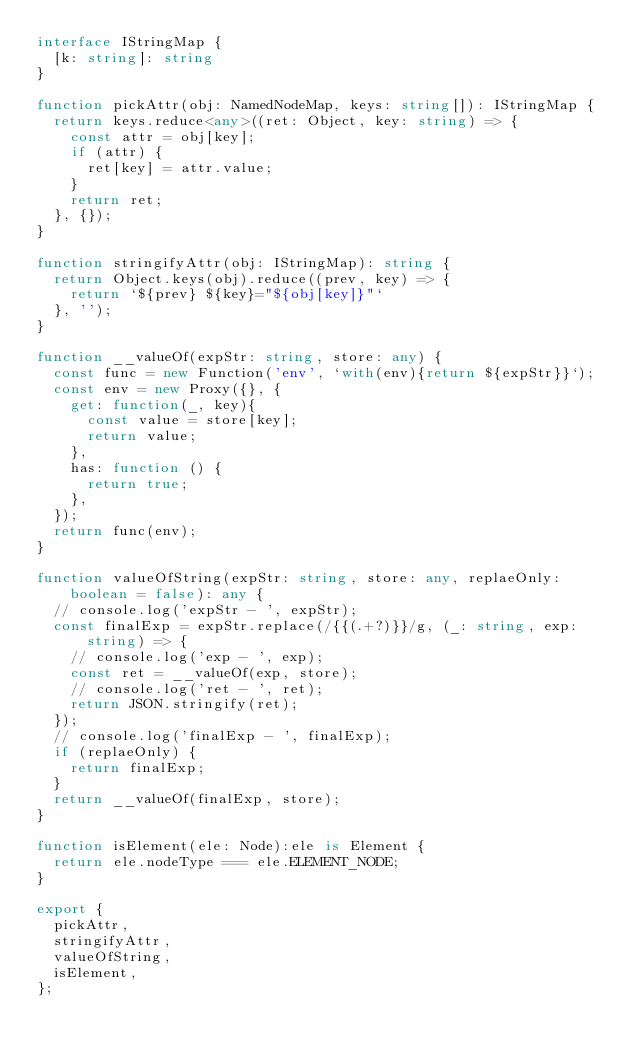Convert code to text. <code><loc_0><loc_0><loc_500><loc_500><_TypeScript_>interface IStringMap {
  [k: string]: string
}

function pickAttr(obj: NamedNodeMap, keys: string[]): IStringMap {
  return keys.reduce<any>((ret: Object, key: string) => {
    const attr = obj[key];
    if (attr) {
      ret[key] = attr.value;
    }
    return ret;
  }, {});
}

function stringifyAttr(obj: IStringMap): string {
  return Object.keys(obj).reduce((prev, key) => {
    return `${prev} ${key}="${obj[key]}"`
  }, '');
}

function __valueOf(expStr: string, store: any) {
  const func = new Function('env', `with(env){return ${expStr}}`);
  const env = new Proxy({}, {
    get: function(_, key){
      const value = store[key];
      return value;
    },
    has: function () {
      return true;
    },
  });
  return func(env);
}

function valueOfString(expStr: string, store: any, replaeOnly: boolean = false): any {
  // console.log('expStr - ', expStr);
  const finalExp = expStr.replace(/{{(.+?)}}/g, (_: string, exp: string) => {
    // console.log('exp - ', exp);
    const ret = __valueOf(exp, store);
    // console.log('ret - ', ret);
    return JSON.stringify(ret);
  });
  // console.log('finalExp - ', finalExp);
  if (replaeOnly) {
    return finalExp;
  }
  return __valueOf(finalExp, store);
}

function isElement(ele: Node):ele is Element {
  return ele.nodeType === ele.ELEMENT_NODE;
}

export {
  pickAttr,
  stringifyAttr,
  valueOfString,
  isElement,
};
</code> 